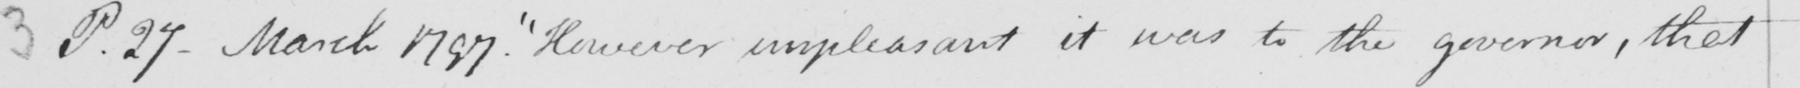What text is written in this handwritten line? P.27 - March 1797 .  " However unpleasant it was to the governor , that 